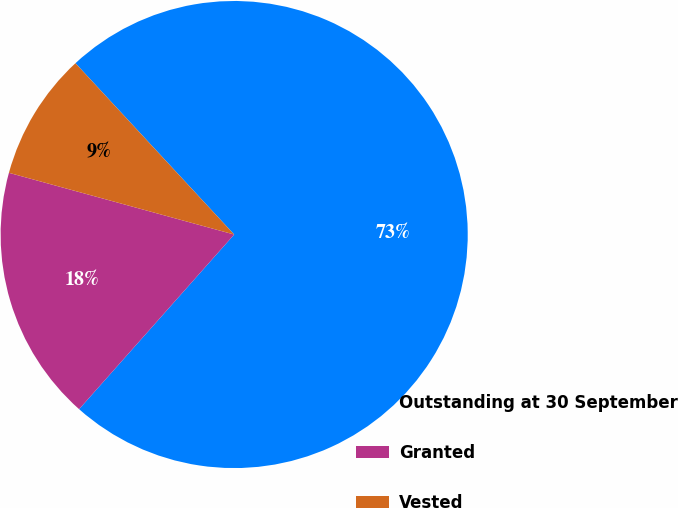<chart> <loc_0><loc_0><loc_500><loc_500><pie_chart><fcel>Outstanding at 30 September<fcel>Granted<fcel>Vested<nl><fcel>73.45%<fcel>17.7%<fcel>8.85%<nl></chart> 